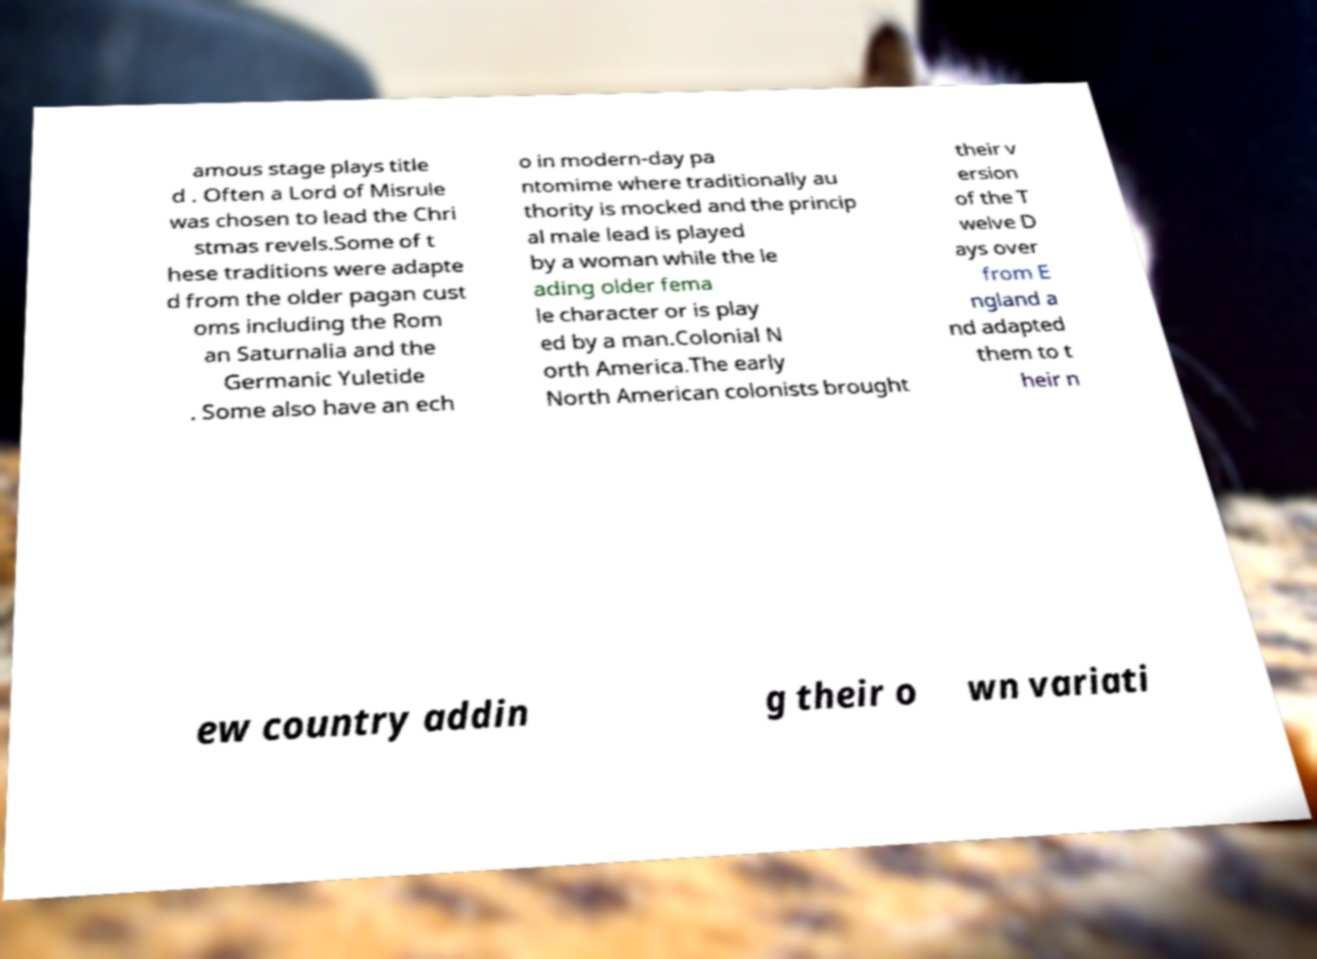Please identify and transcribe the text found in this image. amous stage plays title d . Often a Lord of Misrule was chosen to lead the Chri stmas revels.Some of t hese traditions were adapte d from the older pagan cust oms including the Rom an Saturnalia and the Germanic Yuletide . Some also have an ech o in modern-day pa ntomime where traditionally au thority is mocked and the princip al male lead is played by a woman while the le ading older fema le character or is play ed by a man.Colonial N orth America.The early North American colonists brought their v ersion of the T welve D ays over from E ngland a nd adapted them to t heir n ew country addin g their o wn variati 